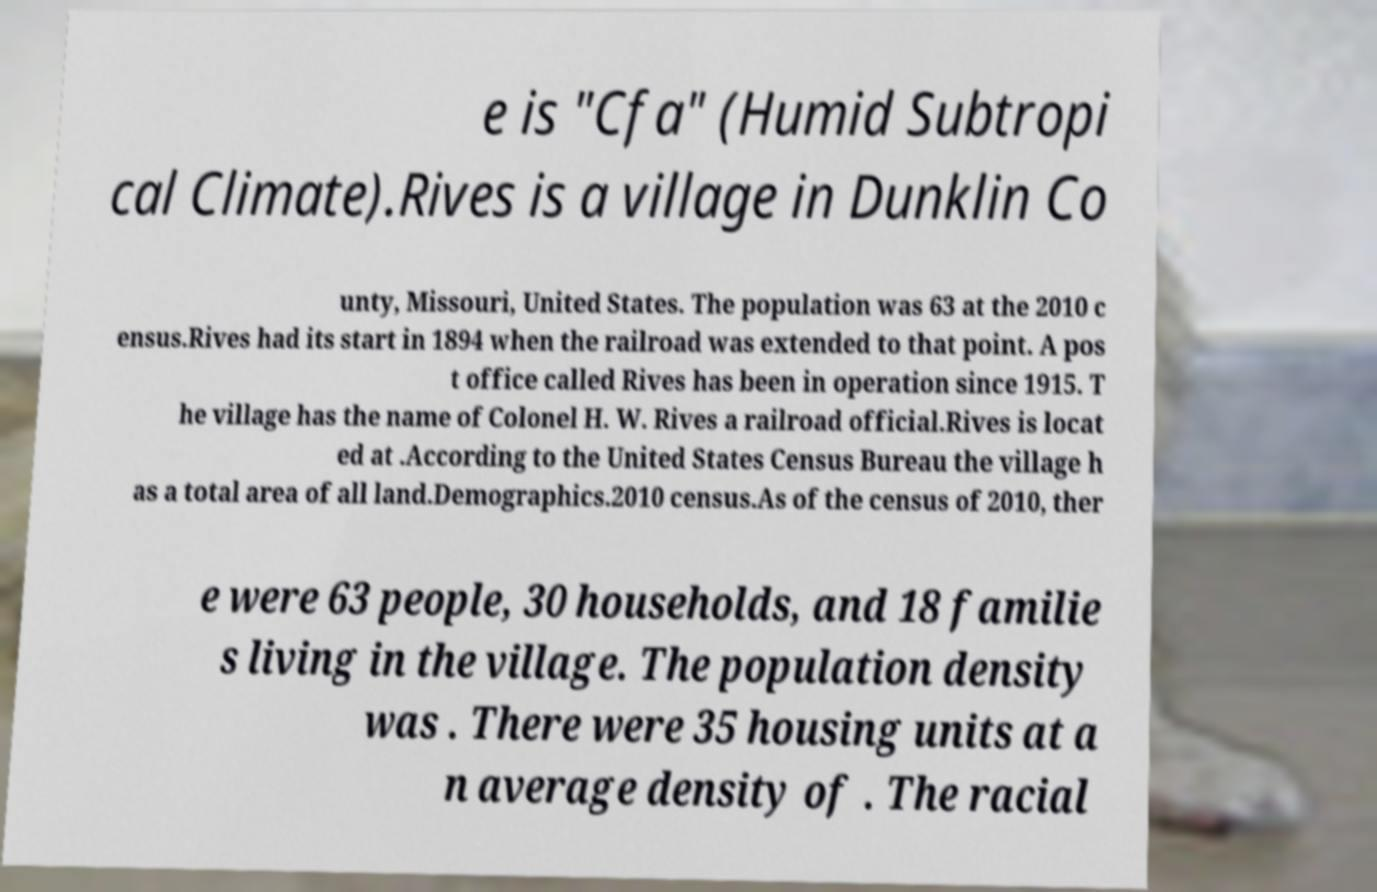Could you extract and type out the text from this image? e is "Cfa" (Humid Subtropi cal Climate).Rives is a village in Dunklin Co unty, Missouri, United States. The population was 63 at the 2010 c ensus.Rives had its start in 1894 when the railroad was extended to that point. A pos t office called Rives has been in operation since 1915. T he village has the name of Colonel H. W. Rives a railroad official.Rives is locat ed at .According to the United States Census Bureau the village h as a total area of all land.Demographics.2010 census.As of the census of 2010, ther e were 63 people, 30 households, and 18 familie s living in the village. The population density was . There were 35 housing units at a n average density of . The racial 